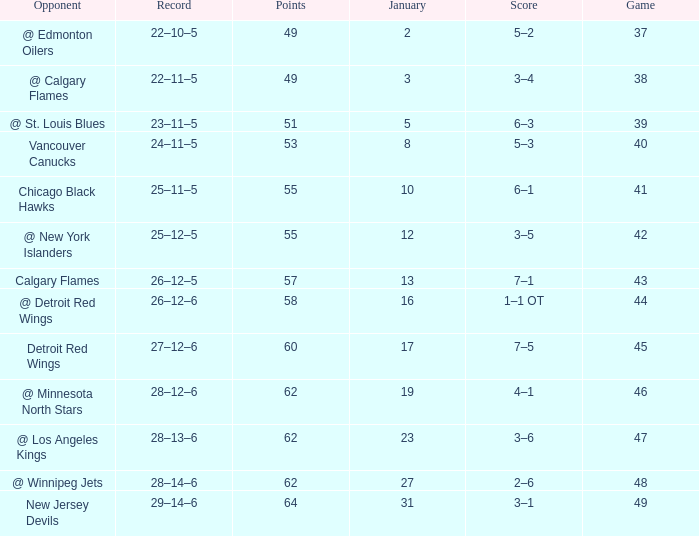How much January has a Record of 26–12–6, and Points smaller than 58? None. Write the full table. {'header': ['Opponent', 'Record', 'Points', 'January', 'Score', 'Game'], 'rows': [['@ Edmonton Oilers', '22–10–5', '49', '2', '5–2', '37'], ['@ Calgary Flames', '22–11–5', '49', '3', '3–4', '38'], ['@ St. Louis Blues', '23–11–5', '51', '5', '6–3', '39'], ['Vancouver Canucks', '24–11–5', '53', '8', '5–3', '40'], ['Chicago Black Hawks', '25–11–5', '55', '10', '6–1', '41'], ['@ New York Islanders', '25–12–5', '55', '12', '3–5', '42'], ['Calgary Flames', '26–12–5', '57', '13', '7–1', '43'], ['@ Detroit Red Wings', '26–12–6', '58', '16', '1–1 OT', '44'], ['Detroit Red Wings', '27–12–6', '60', '17', '7–5', '45'], ['@ Minnesota North Stars', '28–12–6', '62', '19', '4–1', '46'], ['@ Los Angeles Kings', '28–13–6', '62', '23', '3–6', '47'], ['@ Winnipeg Jets', '28–14–6', '62', '27', '2–6', '48'], ['New Jersey Devils', '29–14–6', '64', '31', '3–1', '49']]} 